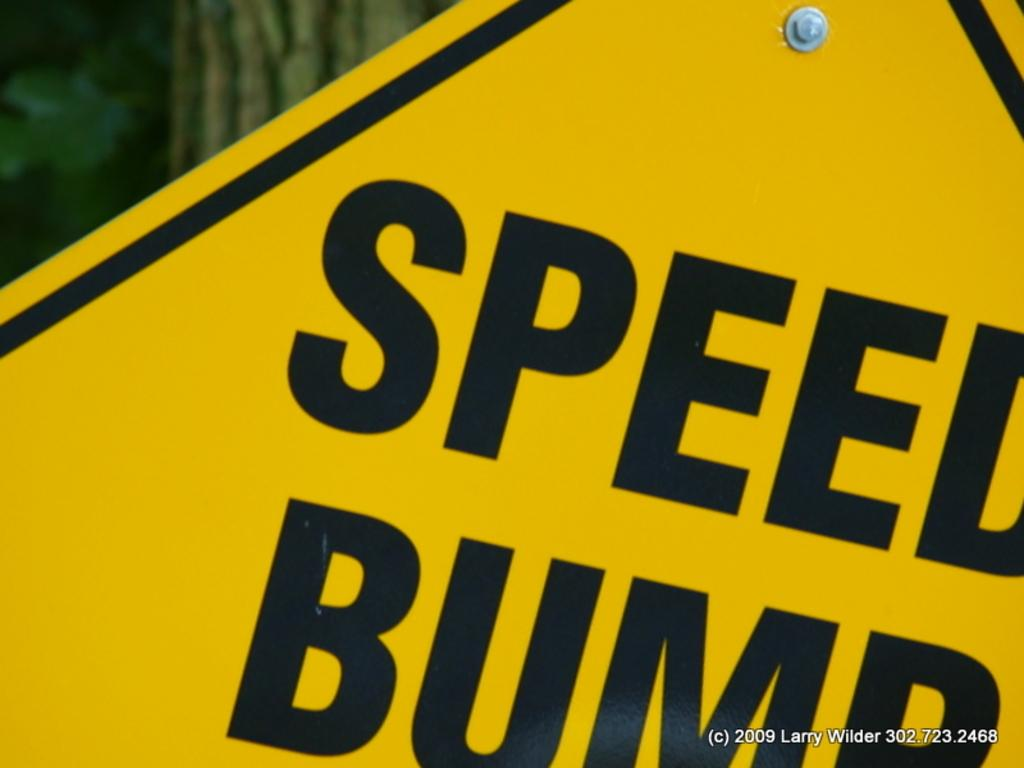<image>
Relay a brief, clear account of the picture shown. a yellow street sing hat says speed bump. 